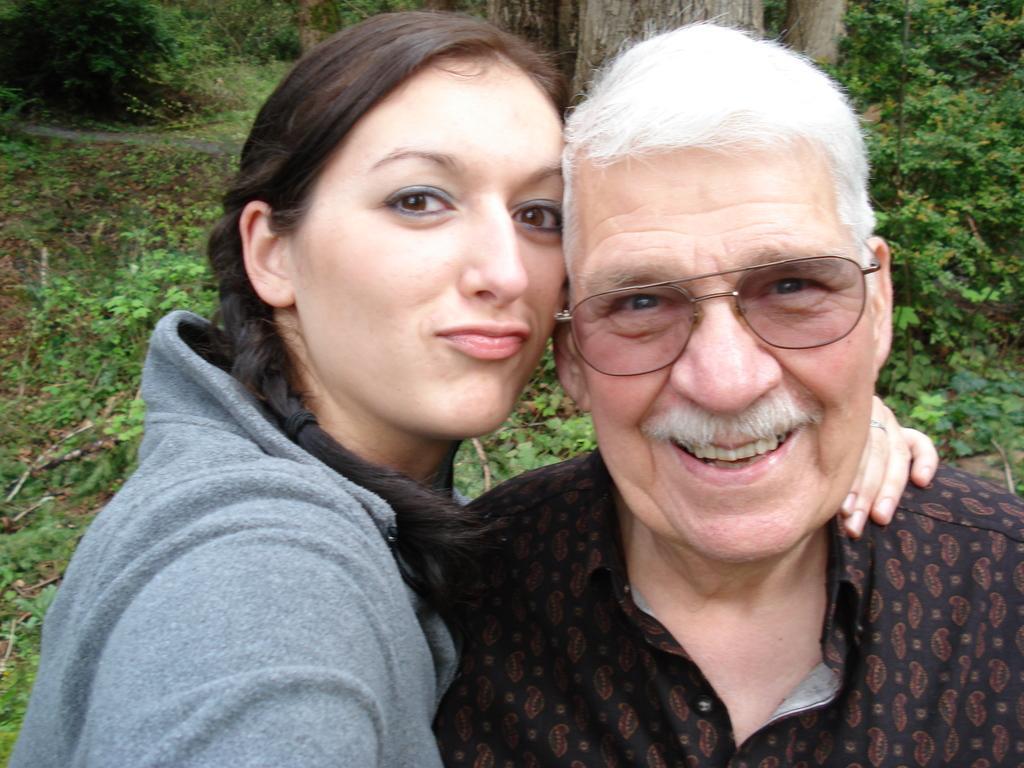In one or two sentences, can you explain what this image depicts? In this picture we can see two people smiling and a man wore spectacles. At the back of them we can see plants and trees on the ground. 